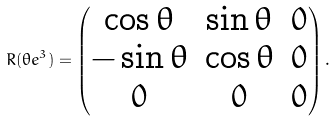Convert formula to latex. <formula><loc_0><loc_0><loc_500><loc_500>R ( \theta e ^ { 3 } ) = \begin{pmatrix} \cos \theta & \sin \theta & 0 \\ - \sin \theta & \cos \theta & 0 \\ 0 & 0 & 0 \end{pmatrix} .</formula> 